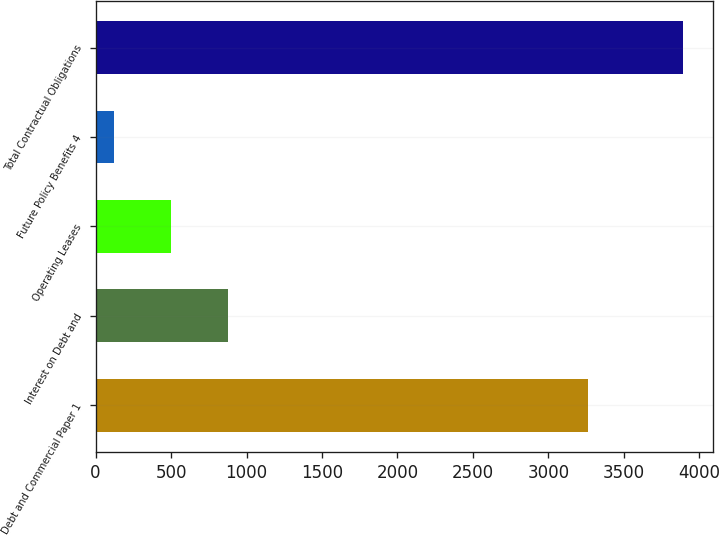<chart> <loc_0><loc_0><loc_500><loc_500><bar_chart><fcel>Debt and Commercial Paper 1<fcel>Interest on Debt and<fcel>Operating Leases<fcel>Future Policy Benefits 4<fcel>Total Contractual Obligations<nl><fcel>3261<fcel>874.6<fcel>497.3<fcel>120<fcel>3893<nl></chart> 